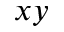<formula> <loc_0><loc_0><loc_500><loc_500>x y</formula> 